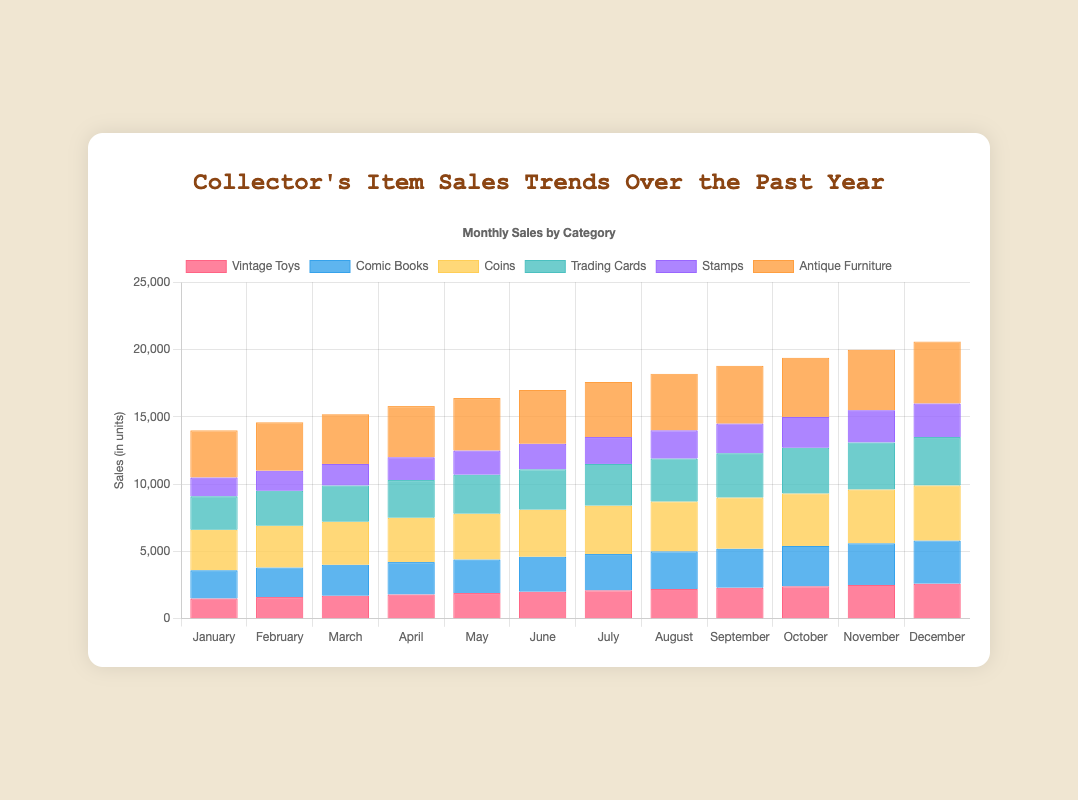Which month had the highest total sales across all categories? By summing the sales figures for all categories for each month, we can see that December has the highest total sales. Summing the figures: 2600 (Vintage Toys) + 3200 (Comic Books) + 4100 (Coins) + 3600 (Trading Cards) + 2500 (Stamps) + 4600 (Antique Furniture) = 20600. Therefore, December has the highest total sales.
Answer: December Which category had the lowest sales in January? By examining the sales figures for January for each category, we can see that Stamps had the lowest sales. The figures are: 1500 (Vintage Toys), 2100 (Comic Books), 3000 (Coins), 2500 (Trading Cards), 1400 (Stamps), and 3500 (Antique Furniture). The lowest value is 1400, which corresponds to Stamps.
Answer: Stamps How many categories had their sales figure increase every month? By examining the sales trend for each category over the months, we can see that "Vintage Toys", "Comic Books", "Coins", "Trading Cards", "Stamps", and "Antique Furniture" all show an increase in sales every month. Hence, all six categories had increasing sales figures every month.
Answer: 6 What is the difference in sales for "Antique Furniture" between January and December? The sales for "Antique Furniture" in January is 3500, and in December it is 4600. The difference is calculated as 4600 - 3500 = 1100.
Answer: 1100 Which category showed the highest sales growth from January to December? To find the sales growth, we calculate the difference between December and January sales for each category. The growths are 1100 (Vintage Toys), 1100 (Comic Books), 1100 (Coins), 1100 (Trading Cards), 1100 (Stamps), and 1100 (Antique Furniture). All categories show the same highest sales growth of 1100 units.
Answer: All categories What are the total sales for "Coins" over the year? Summing the sales figures for "Coins" across all twelve months: 3000 + 3100 + 3200 + 3300 + 3400 + 3500 + 3600 + 3700 + 3800 + 3900 + 4000 + 4100 = 44600.
Answer: 44600 In which month did "Trading Cards" surpass "Comic Books" in sales? By comparing the sales figures for "Trading Cards" and "Comic Books" month by month, we notice that in January, February, March, April, and May, "Trading Cards" sales were lower than "Comic Books." Starting from June, "Trading Cards" (3000) surpassed "Comic Books" (2600) in sales.
Answer: June 